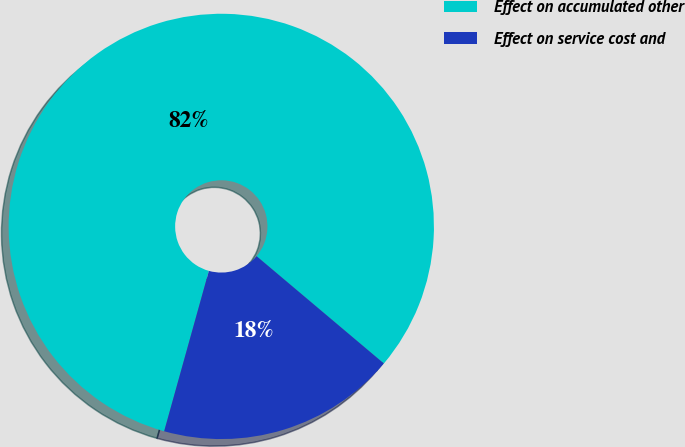Convert chart to OTSL. <chart><loc_0><loc_0><loc_500><loc_500><pie_chart><fcel>Effect on accumulated other<fcel>Effect on service cost and<nl><fcel>81.82%<fcel>18.18%<nl></chart> 